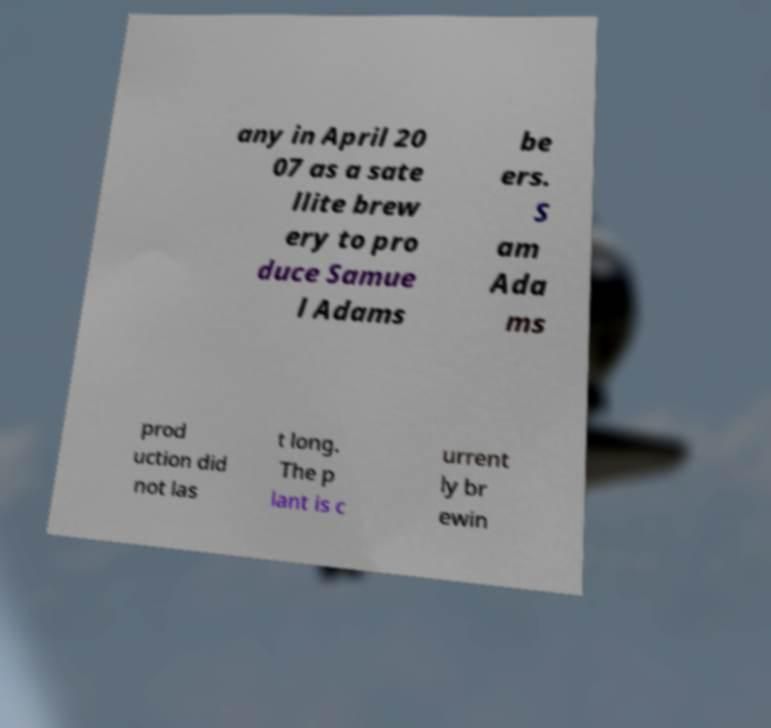Could you extract and type out the text from this image? any in April 20 07 as a sate llite brew ery to pro duce Samue l Adams be ers. S am Ada ms prod uction did not las t long. The p lant is c urrent ly br ewin 